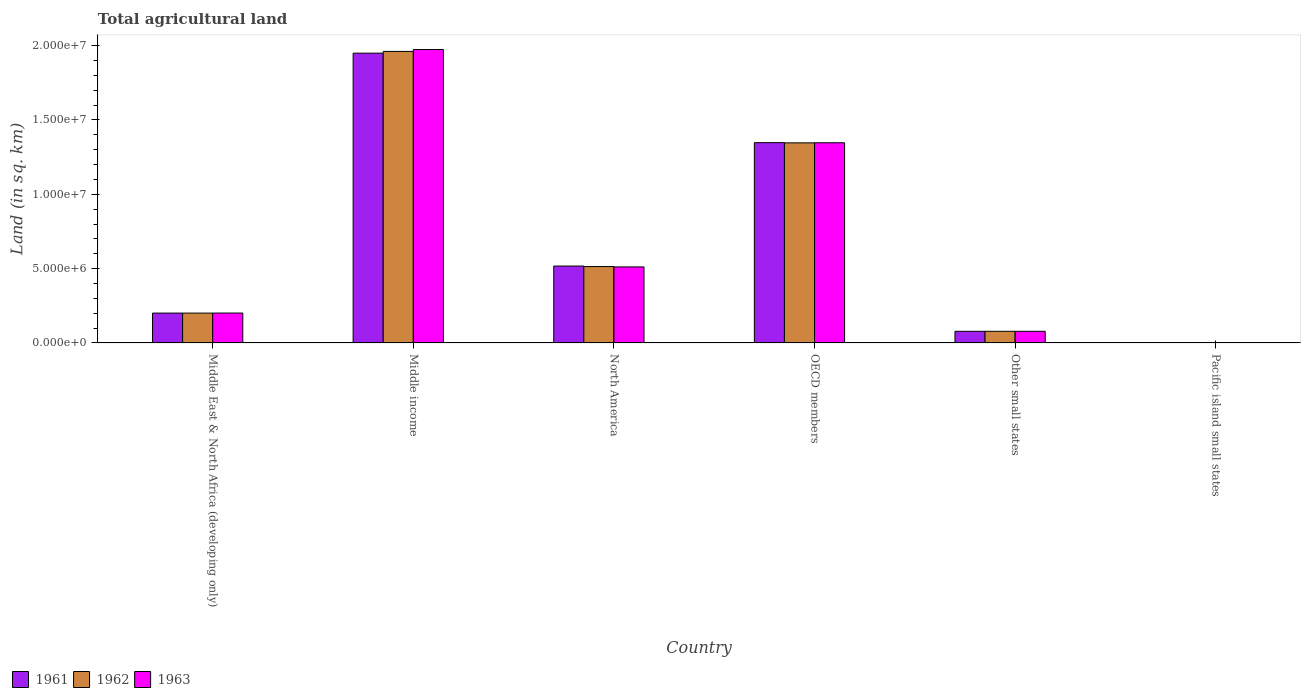Are the number of bars per tick equal to the number of legend labels?
Ensure brevity in your answer.  Yes. Are the number of bars on each tick of the X-axis equal?
Your response must be concise. Yes. How many bars are there on the 1st tick from the left?
Provide a succinct answer. 3. How many bars are there on the 4th tick from the right?
Provide a succinct answer. 3. In how many cases, is the number of bars for a given country not equal to the number of legend labels?
Give a very brief answer. 0. What is the total agricultural land in 1963 in North America?
Your answer should be compact. 5.12e+06. Across all countries, what is the maximum total agricultural land in 1963?
Provide a succinct answer. 1.97e+07. Across all countries, what is the minimum total agricultural land in 1962?
Your answer should be compact. 5130. In which country was the total agricultural land in 1963 maximum?
Provide a succinct answer. Middle income. In which country was the total agricultural land in 1963 minimum?
Make the answer very short. Pacific island small states. What is the total total agricultural land in 1961 in the graph?
Your response must be concise. 4.09e+07. What is the difference between the total agricultural land in 1961 in Middle East & North Africa (developing only) and that in Pacific island small states?
Give a very brief answer. 2.00e+06. What is the difference between the total agricultural land in 1963 in North America and the total agricultural land in 1961 in Pacific island small states?
Your response must be concise. 5.11e+06. What is the average total agricultural land in 1962 per country?
Make the answer very short. 6.83e+06. What is the difference between the total agricultural land of/in 1963 and total agricultural land of/in 1962 in Other small states?
Offer a terse response. 170. In how many countries, is the total agricultural land in 1961 greater than 6000000 sq.km?
Your response must be concise. 2. What is the ratio of the total agricultural land in 1961 in Middle East & North Africa (developing only) to that in Other small states?
Offer a very short reply. 2.57. Is the difference between the total agricultural land in 1963 in Other small states and Pacific island small states greater than the difference between the total agricultural land in 1962 in Other small states and Pacific island small states?
Your answer should be very brief. Yes. What is the difference between the highest and the second highest total agricultural land in 1961?
Your answer should be compact. -1.43e+07. What is the difference between the highest and the lowest total agricultural land in 1961?
Keep it short and to the point. 1.95e+07. Is the sum of the total agricultural land in 1961 in Middle income and Pacific island small states greater than the maximum total agricultural land in 1962 across all countries?
Offer a terse response. No. What does the 1st bar from the right in Other small states represents?
Provide a short and direct response. 1963. Is it the case that in every country, the sum of the total agricultural land in 1963 and total agricultural land in 1961 is greater than the total agricultural land in 1962?
Give a very brief answer. Yes. How many bars are there?
Ensure brevity in your answer.  18. What is the difference between two consecutive major ticks on the Y-axis?
Your answer should be compact. 5.00e+06. Does the graph contain any zero values?
Your answer should be very brief. No. Does the graph contain grids?
Your response must be concise. No. Where does the legend appear in the graph?
Provide a succinct answer. Bottom left. How are the legend labels stacked?
Your response must be concise. Horizontal. What is the title of the graph?
Your answer should be very brief. Total agricultural land. What is the label or title of the X-axis?
Keep it short and to the point. Country. What is the label or title of the Y-axis?
Offer a terse response. Land (in sq. km). What is the Land (in sq. km) of 1961 in Middle East & North Africa (developing only)?
Offer a very short reply. 2.01e+06. What is the Land (in sq. km) of 1962 in Middle East & North Africa (developing only)?
Give a very brief answer. 2.01e+06. What is the Land (in sq. km) in 1963 in Middle East & North Africa (developing only)?
Provide a succinct answer. 2.01e+06. What is the Land (in sq. km) of 1961 in Middle income?
Offer a terse response. 1.95e+07. What is the Land (in sq. km) of 1962 in Middle income?
Your response must be concise. 1.96e+07. What is the Land (in sq. km) in 1963 in Middle income?
Give a very brief answer. 1.97e+07. What is the Land (in sq. km) in 1961 in North America?
Give a very brief answer. 5.17e+06. What is the Land (in sq. km) of 1962 in North America?
Give a very brief answer. 5.14e+06. What is the Land (in sq. km) of 1963 in North America?
Keep it short and to the point. 5.12e+06. What is the Land (in sq. km) of 1961 in OECD members?
Provide a succinct answer. 1.35e+07. What is the Land (in sq. km) of 1962 in OECD members?
Offer a terse response. 1.35e+07. What is the Land (in sq. km) in 1963 in OECD members?
Make the answer very short. 1.35e+07. What is the Land (in sq. km) of 1961 in Other small states?
Keep it short and to the point. 7.83e+05. What is the Land (in sq. km) in 1962 in Other small states?
Offer a terse response. 7.83e+05. What is the Land (in sq. km) in 1963 in Other small states?
Your answer should be compact. 7.83e+05. What is the Land (in sq. km) of 1961 in Pacific island small states?
Provide a succinct answer. 5110. What is the Land (in sq. km) in 1962 in Pacific island small states?
Make the answer very short. 5130. What is the Land (in sq. km) in 1963 in Pacific island small states?
Offer a very short reply. 5190. Across all countries, what is the maximum Land (in sq. km) of 1961?
Offer a very short reply. 1.95e+07. Across all countries, what is the maximum Land (in sq. km) of 1962?
Keep it short and to the point. 1.96e+07. Across all countries, what is the maximum Land (in sq. km) of 1963?
Your response must be concise. 1.97e+07. Across all countries, what is the minimum Land (in sq. km) in 1961?
Your response must be concise. 5110. Across all countries, what is the minimum Land (in sq. km) in 1962?
Make the answer very short. 5130. Across all countries, what is the minimum Land (in sq. km) of 1963?
Your answer should be very brief. 5190. What is the total Land (in sq. km) of 1961 in the graph?
Your response must be concise. 4.09e+07. What is the total Land (in sq. km) of 1962 in the graph?
Your response must be concise. 4.10e+07. What is the total Land (in sq. km) of 1963 in the graph?
Provide a short and direct response. 4.11e+07. What is the difference between the Land (in sq. km) in 1961 in Middle East & North Africa (developing only) and that in Middle income?
Your response must be concise. -1.75e+07. What is the difference between the Land (in sq. km) of 1962 in Middle East & North Africa (developing only) and that in Middle income?
Keep it short and to the point. -1.76e+07. What is the difference between the Land (in sq. km) of 1963 in Middle East & North Africa (developing only) and that in Middle income?
Keep it short and to the point. -1.77e+07. What is the difference between the Land (in sq. km) of 1961 in Middle East & North Africa (developing only) and that in North America?
Offer a terse response. -3.16e+06. What is the difference between the Land (in sq. km) in 1962 in Middle East & North Africa (developing only) and that in North America?
Your answer should be very brief. -3.13e+06. What is the difference between the Land (in sq. km) of 1963 in Middle East & North Africa (developing only) and that in North America?
Your answer should be compact. -3.10e+06. What is the difference between the Land (in sq. km) in 1961 in Middle East & North Africa (developing only) and that in OECD members?
Give a very brief answer. -1.15e+07. What is the difference between the Land (in sq. km) in 1962 in Middle East & North Africa (developing only) and that in OECD members?
Give a very brief answer. -1.15e+07. What is the difference between the Land (in sq. km) of 1963 in Middle East & North Africa (developing only) and that in OECD members?
Offer a very short reply. -1.15e+07. What is the difference between the Land (in sq. km) of 1961 in Middle East & North Africa (developing only) and that in Other small states?
Offer a terse response. 1.23e+06. What is the difference between the Land (in sq. km) of 1962 in Middle East & North Africa (developing only) and that in Other small states?
Offer a very short reply. 1.22e+06. What is the difference between the Land (in sq. km) of 1963 in Middle East & North Africa (developing only) and that in Other small states?
Ensure brevity in your answer.  1.23e+06. What is the difference between the Land (in sq. km) in 1961 in Middle East & North Africa (developing only) and that in Pacific island small states?
Provide a succinct answer. 2.00e+06. What is the difference between the Land (in sq. km) of 1962 in Middle East & North Africa (developing only) and that in Pacific island small states?
Keep it short and to the point. 2.00e+06. What is the difference between the Land (in sq. km) in 1963 in Middle East & North Africa (developing only) and that in Pacific island small states?
Provide a succinct answer. 2.01e+06. What is the difference between the Land (in sq. km) of 1961 in Middle income and that in North America?
Make the answer very short. 1.43e+07. What is the difference between the Land (in sq. km) in 1962 in Middle income and that in North America?
Your response must be concise. 1.45e+07. What is the difference between the Land (in sq. km) of 1963 in Middle income and that in North America?
Your answer should be very brief. 1.46e+07. What is the difference between the Land (in sq. km) of 1961 in Middle income and that in OECD members?
Provide a short and direct response. 6.02e+06. What is the difference between the Land (in sq. km) of 1962 in Middle income and that in OECD members?
Offer a terse response. 6.15e+06. What is the difference between the Land (in sq. km) in 1963 in Middle income and that in OECD members?
Provide a succinct answer. 6.27e+06. What is the difference between the Land (in sq. km) of 1961 in Middle income and that in Other small states?
Give a very brief answer. 1.87e+07. What is the difference between the Land (in sq. km) in 1962 in Middle income and that in Other small states?
Make the answer very short. 1.88e+07. What is the difference between the Land (in sq. km) in 1963 in Middle income and that in Other small states?
Your answer should be very brief. 1.90e+07. What is the difference between the Land (in sq. km) in 1961 in Middle income and that in Pacific island small states?
Offer a very short reply. 1.95e+07. What is the difference between the Land (in sq. km) in 1962 in Middle income and that in Pacific island small states?
Ensure brevity in your answer.  1.96e+07. What is the difference between the Land (in sq. km) in 1963 in Middle income and that in Pacific island small states?
Make the answer very short. 1.97e+07. What is the difference between the Land (in sq. km) in 1961 in North America and that in OECD members?
Provide a short and direct response. -8.30e+06. What is the difference between the Land (in sq. km) of 1962 in North America and that in OECD members?
Give a very brief answer. -8.32e+06. What is the difference between the Land (in sq. km) in 1963 in North America and that in OECD members?
Your answer should be very brief. -8.35e+06. What is the difference between the Land (in sq. km) in 1961 in North America and that in Other small states?
Your response must be concise. 4.39e+06. What is the difference between the Land (in sq. km) in 1962 in North America and that in Other small states?
Offer a terse response. 4.36e+06. What is the difference between the Land (in sq. km) of 1963 in North America and that in Other small states?
Provide a short and direct response. 4.33e+06. What is the difference between the Land (in sq. km) in 1961 in North America and that in Pacific island small states?
Make the answer very short. 5.17e+06. What is the difference between the Land (in sq. km) of 1962 in North America and that in Pacific island small states?
Provide a short and direct response. 5.13e+06. What is the difference between the Land (in sq. km) of 1963 in North America and that in Pacific island small states?
Provide a succinct answer. 5.11e+06. What is the difference between the Land (in sq. km) of 1961 in OECD members and that in Other small states?
Your response must be concise. 1.27e+07. What is the difference between the Land (in sq. km) of 1962 in OECD members and that in Other small states?
Your answer should be compact. 1.27e+07. What is the difference between the Land (in sq. km) of 1963 in OECD members and that in Other small states?
Your answer should be very brief. 1.27e+07. What is the difference between the Land (in sq. km) of 1961 in OECD members and that in Pacific island small states?
Make the answer very short. 1.35e+07. What is the difference between the Land (in sq. km) of 1962 in OECD members and that in Pacific island small states?
Your response must be concise. 1.35e+07. What is the difference between the Land (in sq. km) in 1963 in OECD members and that in Pacific island small states?
Keep it short and to the point. 1.35e+07. What is the difference between the Land (in sq. km) of 1961 in Other small states and that in Pacific island small states?
Provide a short and direct response. 7.78e+05. What is the difference between the Land (in sq. km) in 1962 in Other small states and that in Pacific island small states?
Your answer should be very brief. 7.78e+05. What is the difference between the Land (in sq. km) of 1963 in Other small states and that in Pacific island small states?
Provide a succinct answer. 7.78e+05. What is the difference between the Land (in sq. km) of 1961 in Middle East & North Africa (developing only) and the Land (in sq. km) of 1962 in Middle income?
Your answer should be very brief. -1.76e+07. What is the difference between the Land (in sq. km) in 1961 in Middle East & North Africa (developing only) and the Land (in sq. km) in 1963 in Middle income?
Offer a terse response. -1.77e+07. What is the difference between the Land (in sq. km) of 1962 in Middle East & North Africa (developing only) and the Land (in sq. km) of 1963 in Middle income?
Offer a very short reply. -1.77e+07. What is the difference between the Land (in sq. km) in 1961 in Middle East & North Africa (developing only) and the Land (in sq. km) in 1962 in North America?
Ensure brevity in your answer.  -3.13e+06. What is the difference between the Land (in sq. km) of 1961 in Middle East & North Africa (developing only) and the Land (in sq. km) of 1963 in North America?
Make the answer very short. -3.11e+06. What is the difference between the Land (in sq. km) of 1962 in Middle East & North Africa (developing only) and the Land (in sq. km) of 1963 in North America?
Ensure brevity in your answer.  -3.11e+06. What is the difference between the Land (in sq. km) in 1961 in Middle East & North Africa (developing only) and the Land (in sq. km) in 1962 in OECD members?
Ensure brevity in your answer.  -1.15e+07. What is the difference between the Land (in sq. km) in 1961 in Middle East & North Africa (developing only) and the Land (in sq. km) in 1963 in OECD members?
Provide a short and direct response. -1.15e+07. What is the difference between the Land (in sq. km) in 1962 in Middle East & North Africa (developing only) and the Land (in sq. km) in 1963 in OECD members?
Your answer should be very brief. -1.15e+07. What is the difference between the Land (in sq. km) of 1961 in Middle East & North Africa (developing only) and the Land (in sq. km) of 1962 in Other small states?
Provide a short and direct response. 1.23e+06. What is the difference between the Land (in sq. km) in 1961 in Middle East & North Africa (developing only) and the Land (in sq. km) in 1963 in Other small states?
Provide a succinct answer. 1.23e+06. What is the difference between the Land (in sq. km) of 1962 in Middle East & North Africa (developing only) and the Land (in sq. km) of 1963 in Other small states?
Your answer should be compact. 1.22e+06. What is the difference between the Land (in sq. km) of 1961 in Middle East & North Africa (developing only) and the Land (in sq. km) of 1962 in Pacific island small states?
Make the answer very short. 2.00e+06. What is the difference between the Land (in sq. km) in 1961 in Middle East & North Africa (developing only) and the Land (in sq. km) in 1963 in Pacific island small states?
Make the answer very short. 2.00e+06. What is the difference between the Land (in sq. km) in 1962 in Middle East & North Africa (developing only) and the Land (in sq. km) in 1963 in Pacific island small states?
Your response must be concise. 2.00e+06. What is the difference between the Land (in sq. km) of 1961 in Middle income and the Land (in sq. km) of 1962 in North America?
Provide a short and direct response. 1.44e+07. What is the difference between the Land (in sq. km) in 1961 in Middle income and the Land (in sq. km) in 1963 in North America?
Your answer should be very brief. 1.44e+07. What is the difference between the Land (in sq. km) of 1962 in Middle income and the Land (in sq. km) of 1963 in North America?
Offer a very short reply. 1.45e+07. What is the difference between the Land (in sq. km) of 1961 in Middle income and the Land (in sq. km) of 1962 in OECD members?
Your answer should be compact. 6.03e+06. What is the difference between the Land (in sq. km) of 1961 in Middle income and the Land (in sq. km) of 1963 in OECD members?
Make the answer very short. 6.03e+06. What is the difference between the Land (in sq. km) of 1962 in Middle income and the Land (in sq. km) of 1963 in OECD members?
Offer a terse response. 6.15e+06. What is the difference between the Land (in sq. km) of 1961 in Middle income and the Land (in sq. km) of 1962 in Other small states?
Your response must be concise. 1.87e+07. What is the difference between the Land (in sq. km) in 1961 in Middle income and the Land (in sq. km) in 1963 in Other small states?
Provide a short and direct response. 1.87e+07. What is the difference between the Land (in sq. km) of 1962 in Middle income and the Land (in sq. km) of 1963 in Other small states?
Offer a very short reply. 1.88e+07. What is the difference between the Land (in sq. km) of 1961 in Middle income and the Land (in sq. km) of 1962 in Pacific island small states?
Offer a very short reply. 1.95e+07. What is the difference between the Land (in sq. km) of 1961 in Middle income and the Land (in sq. km) of 1963 in Pacific island small states?
Ensure brevity in your answer.  1.95e+07. What is the difference between the Land (in sq. km) in 1962 in Middle income and the Land (in sq. km) in 1963 in Pacific island small states?
Your response must be concise. 1.96e+07. What is the difference between the Land (in sq. km) of 1961 in North America and the Land (in sq. km) of 1962 in OECD members?
Your response must be concise. -8.29e+06. What is the difference between the Land (in sq. km) of 1961 in North America and the Land (in sq. km) of 1963 in OECD members?
Your answer should be very brief. -8.29e+06. What is the difference between the Land (in sq. km) in 1962 in North America and the Land (in sq. km) in 1963 in OECD members?
Provide a succinct answer. -8.33e+06. What is the difference between the Land (in sq. km) in 1961 in North America and the Land (in sq. km) in 1962 in Other small states?
Ensure brevity in your answer.  4.39e+06. What is the difference between the Land (in sq. km) of 1961 in North America and the Land (in sq. km) of 1963 in Other small states?
Offer a terse response. 4.39e+06. What is the difference between the Land (in sq. km) of 1962 in North America and the Land (in sq. km) of 1963 in Other small states?
Give a very brief answer. 4.36e+06. What is the difference between the Land (in sq. km) of 1961 in North America and the Land (in sq. km) of 1962 in Pacific island small states?
Make the answer very short. 5.17e+06. What is the difference between the Land (in sq. km) in 1961 in North America and the Land (in sq. km) in 1963 in Pacific island small states?
Ensure brevity in your answer.  5.17e+06. What is the difference between the Land (in sq. km) in 1962 in North America and the Land (in sq. km) in 1963 in Pacific island small states?
Make the answer very short. 5.13e+06. What is the difference between the Land (in sq. km) in 1961 in OECD members and the Land (in sq. km) in 1962 in Other small states?
Your answer should be very brief. 1.27e+07. What is the difference between the Land (in sq. km) in 1961 in OECD members and the Land (in sq. km) in 1963 in Other small states?
Ensure brevity in your answer.  1.27e+07. What is the difference between the Land (in sq. km) in 1962 in OECD members and the Land (in sq. km) in 1963 in Other small states?
Make the answer very short. 1.27e+07. What is the difference between the Land (in sq. km) in 1961 in OECD members and the Land (in sq. km) in 1962 in Pacific island small states?
Your response must be concise. 1.35e+07. What is the difference between the Land (in sq. km) in 1961 in OECD members and the Land (in sq. km) in 1963 in Pacific island small states?
Make the answer very short. 1.35e+07. What is the difference between the Land (in sq. km) in 1962 in OECD members and the Land (in sq. km) in 1963 in Pacific island small states?
Your response must be concise. 1.35e+07. What is the difference between the Land (in sq. km) in 1961 in Other small states and the Land (in sq. km) in 1962 in Pacific island small states?
Offer a very short reply. 7.78e+05. What is the difference between the Land (in sq. km) in 1961 in Other small states and the Land (in sq. km) in 1963 in Pacific island small states?
Ensure brevity in your answer.  7.78e+05. What is the difference between the Land (in sq. km) in 1962 in Other small states and the Land (in sq. km) in 1963 in Pacific island small states?
Ensure brevity in your answer.  7.78e+05. What is the average Land (in sq. km) in 1961 per country?
Offer a very short reply. 6.82e+06. What is the average Land (in sq. km) of 1962 per country?
Your answer should be very brief. 6.83e+06. What is the average Land (in sq. km) of 1963 per country?
Your answer should be very brief. 6.85e+06. What is the difference between the Land (in sq. km) of 1961 and Land (in sq. km) of 1962 in Middle East & North Africa (developing only)?
Your answer should be very brief. 1080. What is the difference between the Land (in sq. km) of 1961 and Land (in sq. km) of 1963 in Middle East & North Africa (developing only)?
Ensure brevity in your answer.  -1370. What is the difference between the Land (in sq. km) of 1962 and Land (in sq. km) of 1963 in Middle East & North Africa (developing only)?
Provide a short and direct response. -2450. What is the difference between the Land (in sq. km) in 1961 and Land (in sq. km) in 1962 in Middle income?
Your response must be concise. -1.17e+05. What is the difference between the Land (in sq. km) of 1961 and Land (in sq. km) of 1963 in Middle income?
Offer a very short reply. -2.43e+05. What is the difference between the Land (in sq. km) of 1962 and Land (in sq. km) of 1963 in Middle income?
Offer a terse response. -1.26e+05. What is the difference between the Land (in sq. km) of 1961 and Land (in sq. km) of 1962 in North America?
Your response must be concise. 3.39e+04. What is the difference between the Land (in sq. km) of 1961 and Land (in sq. km) of 1963 in North America?
Provide a succinct answer. 5.81e+04. What is the difference between the Land (in sq. km) in 1962 and Land (in sq. km) in 1963 in North America?
Offer a very short reply. 2.42e+04. What is the difference between the Land (in sq. km) in 1961 and Land (in sq. km) in 1962 in OECD members?
Ensure brevity in your answer.  1.42e+04. What is the difference between the Land (in sq. km) in 1961 and Land (in sq. km) in 1963 in OECD members?
Your answer should be compact. 8693. What is the difference between the Land (in sq. km) of 1962 and Land (in sq. km) of 1963 in OECD members?
Give a very brief answer. -5492. What is the difference between the Land (in sq. km) in 1961 and Land (in sq. km) in 1962 in Other small states?
Your answer should be very brief. -290. What is the difference between the Land (in sq. km) of 1961 and Land (in sq. km) of 1963 in Other small states?
Ensure brevity in your answer.  -460. What is the difference between the Land (in sq. km) in 1962 and Land (in sq. km) in 1963 in Other small states?
Your response must be concise. -170. What is the difference between the Land (in sq. km) in 1961 and Land (in sq. km) in 1963 in Pacific island small states?
Offer a terse response. -80. What is the difference between the Land (in sq. km) in 1962 and Land (in sq. km) in 1963 in Pacific island small states?
Make the answer very short. -60. What is the ratio of the Land (in sq. km) in 1961 in Middle East & North Africa (developing only) to that in Middle income?
Offer a very short reply. 0.1. What is the ratio of the Land (in sq. km) in 1962 in Middle East & North Africa (developing only) to that in Middle income?
Make the answer very short. 0.1. What is the ratio of the Land (in sq. km) of 1963 in Middle East & North Africa (developing only) to that in Middle income?
Provide a succinct answer. 0.1. What is the ratio of the Land (in sq. km) of 1961 in Middle East & North Africa (developing only) to that in North America?
Provide a succinct answer. 0.39. What is the ratio of the Land (in sq. km) in 1962 in Middle East & North Africa (developing only) to that in North America?
Your response must be concise. 0.39. What is the ratio of the Land (in sq. km) of 1963 in Middle East & North Africa (developing only) to that in North America?
Give a very brief answer. 0.39. What is the ratio of the Land (in sq. km) in 1961 in Middle East & North Africa (developing only) to that in OECD members?
Give a very brief answer. 0.15. What is the ratio of the Land (in sq. km) of 1962 in Middle East & North Africa (developing only) to that in OECD members?
Ensure brevity in your answer.  0.15. What is the ratio of the Land (in sq. km) of 1963 in Middle East & North Africa (developing only) to that in OECD members?
Your response must be concise. 0.15. What is the ratio of the Land (in sq. km) of 1961 in Middle East & North Africa (developing only) to that in Other small states?
Keep it short and to the point. 2.57. What is the ratio of the Land (in sq. km) of 1962 in Middle East & North Africa (developing only) to that in Other small states?
Offer a terse response. 2.56. What is the ratio of the Land (in sq. km) in 1963 in Middle East & North Africa (developing only) to that in Other small states?
Your response must be concise. 2.57. What is the ratio of the Land (in sq. km) of 1961 in Middle East & North Africa (developing only) to that in Pacific island small states?
Offer a very short reply. 393.13. What is the ratio of the Land (in sq. km) in 1962 in Middle East & North Africa (developing only) to that in Pacific island small states?
Your answer should be compact. 391.39. What is the ratio of the Land (in sq. km) of 1963 in Middle East & North Africa (developing only) to that in Pacific island small states?
Your response must be concise. 387.33. What is the ratio of the Land (in sq. km) in 1961 in Middle income to that in North America?
Keep it short and to the point. 3.77. What is the ratio of the Land (in sq. km) of 1962 in Middle income to that in North America?
Your response must be concise. 3.82. What is the ratio of the Land (in sq. km) of 1963 in Middle income to that in North America?
Give a very brief answer. 3.86. What is the ratio of the Land (in sq. km) in 1961 in Middle income to that in OECD members?
Provide a short and direct response. 1.45. What is the ratio of the Land (in sq. km) in 1962 in Middle income to that in OECD members?
Ensure brevity in your answer.  1.46. What is the ratio of the Land (in sq. km) in 1963 in Middle income to that in OECD members?
Offer a terse response. 1.47. What is the ratio of the Land (in sq. km) in 1961 in Middle income to that in Other small states?
Offer a very short reply. 24.91. What is the ratio of the Land (in sq. km) in 1962 in Middle income to that in Other small states?
Give a very brief answer. 25.05. What is the ratio of the Land (in sq. km) in 1963 in Middle income to that in Other small states?
Keep it short and to the point. 25.2. What is the ratio of the Land (in sq. km) in 1961 in Middle income to that in Pacific island small states?
Your answer should be compact. 3815.23. What is the ratio of the Land (in sq. km) of 1962 in Middle income to that in Pacific island small states?
Your answer should be compact. 3823.23. What is the ratio of the Land (in sq. km) of 1963 in Middle income to that in Pacific island small states?
Offer a very short reply. 3803.26. What is the ratio of the Land (in sq. km) of 1961 in North America to that in OECD members?
Give a very brief answer. 0.38. What is the ratio of the Land (in sq. km) of 1962 in North America to that in OECD members?
Give a very brief answer. 0.38. What is the ratio of the Land (in sq. km) of 1963 in North America to that in OECD members?
Your answer should be very brief. 0.38. What is the ratio of the Land (in sq. km) of 1961 in North America to that in Other small states?
Your answer should be compact. 6.61. What is the ratio of the Land (in sq. km) of 1962 in North America to that in Other small states?
Make the answer very short. 6.56. What is the ratio of the Land (in sq. km) in 1963 in North America to that in Other small states?
Provide a succinct answer. 6.53. What is the ratio of the Land (in sq. km) in 1961 in North America to that in Pacific island small states?
Give a very brief answer. 1012.4. What is the ratio of the Land (in sq. km) in 1962 in North America to that in Pacific island small states?
Offer a terse response. 1001.84. What is the ratio of the Land (in sq. km) in 1963 in North America to that in Pacific island small states?
Your response must be concise. 985.6. What is the ratio of the Land (in sq. km) in 1961 in OECD members to that in Other small states?
Provide a succinct answer. 17.21. What is the ratio of the Land (in sq. km) in 1962 in OECD members to that in Other small states?
Provide a short and direct response. 17.19. What is the ratio of the Land (in sq. km) in 1963 in OECD members to that in Other small states?
Ensure brevity in your answer.  17.19. What is the ratio of the Land (in sq. km) in 1961 in OECD members to that in Pacific island small states?
Offer a terse response. 2637.03. What is the ratio of the Land (in sq. km) of 1962 in OECD members to that in Pacific island small states?
Your answer should be compact. 2623.99. What is the ratio of the Land (in sq. km) of 1963 in OECD members to that in Pacific island small states?
Keep it short and to the point. 2594.71. What is the ratio of the Land (in sq. km) in 1961 in Other small states to that in Pacific island small states?
Provide a short and direct response. 153.19. What is the ratio of the Land (in sq. km) in 1962 in Other small states to that in Pacific island small states?
Give a very brief answer. 152.65. What is the ratio of the Land (in sq. km) in 1963 in Other small states to that in Pacific island small states?
Offer a terse response. 150.91. What is the difference between the highest and the second highest Land (in sq. km) in 1961?
Make the answer very short. 6.02e+06. What is the difference between the highest and the second highest Land (in sq. km) of 1962?
Your answer should be very brief. 6.15e+06. What is the difference between the highest and the second highest Land (in sq. km) of 1963?
Provide a succinct answer. 6.27e+06. What is the difference between the highest and the lowest Land (in sq. km) of 1961?
Your answer should be very brief. 1.95e+07. What is the difference between the highest and the lowest Land (in sq. km) of 1962?
Make the answer very short. 1.96e+07. What is the difference between the highest and the lowest Land (in sq. km) of 1963?
Offer a terse response. 1.97e+07. 